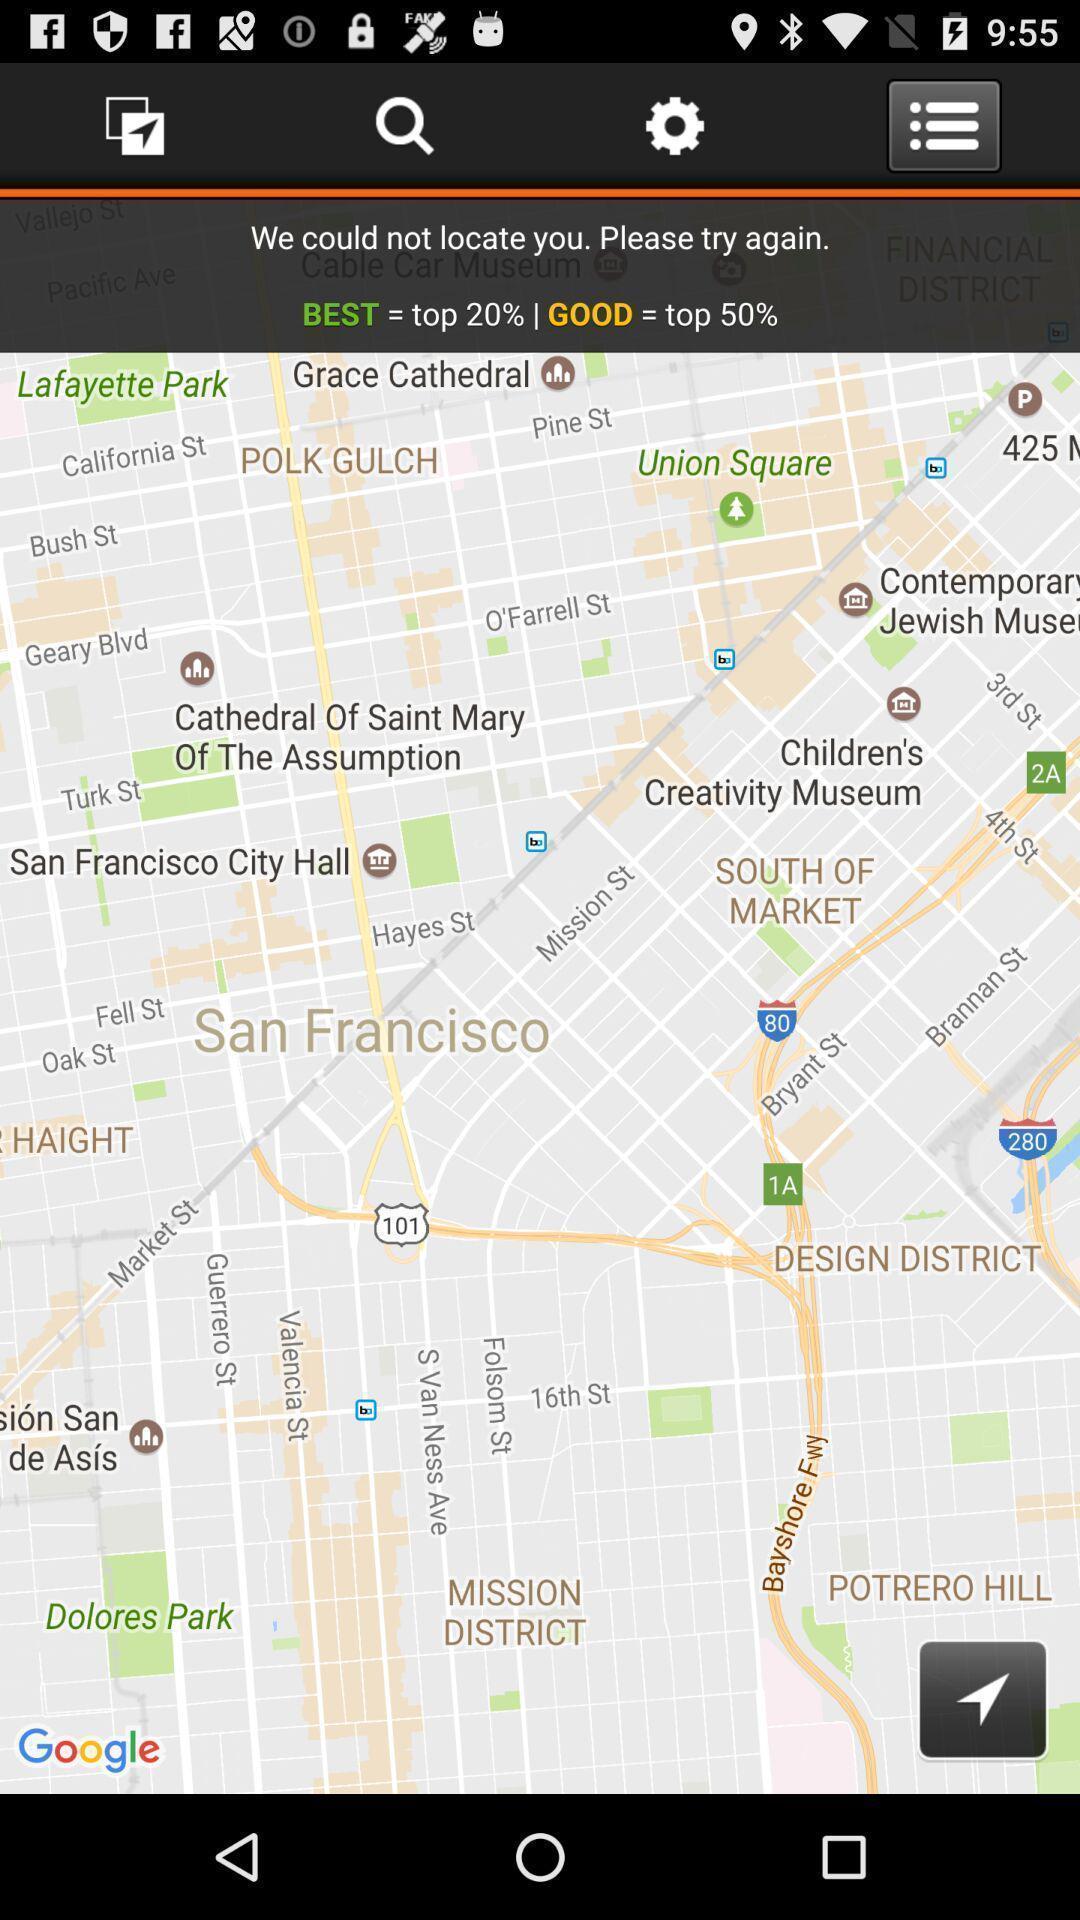What details can you identify in this image? Screen shows the map location. 